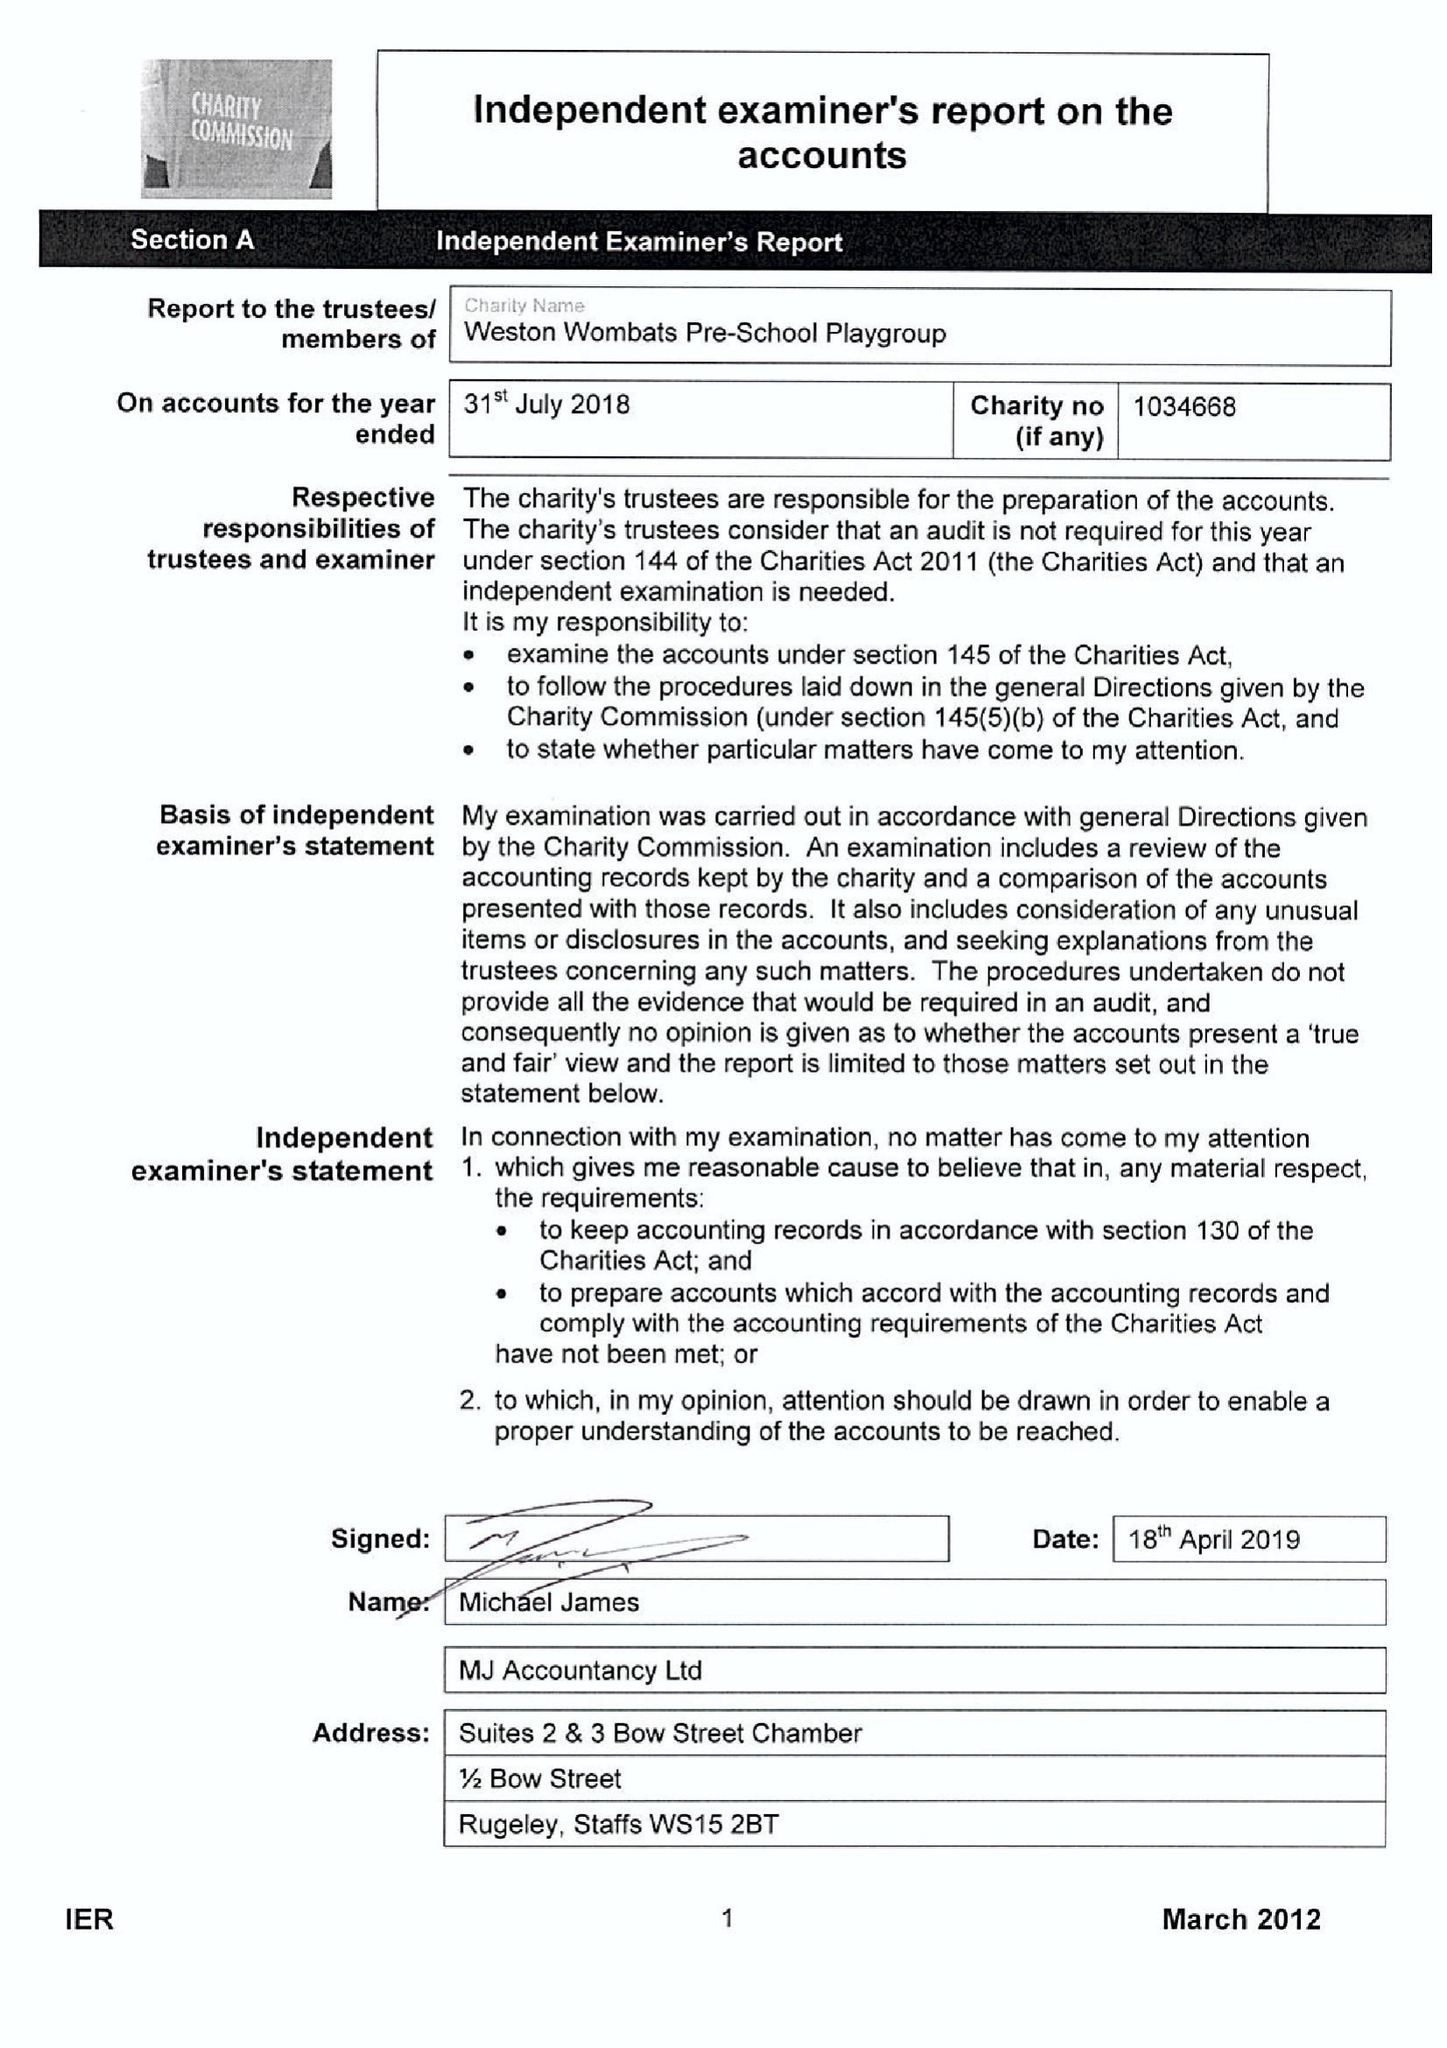What is the value for the report_date?
Answer the question using a single word or phrase. 2018-07-31 